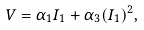<formula> <loc_0><loc_0><loc_500><loc_500>V = \alpha _ { 1 } I _ { 1 } + \alpha _ { 3 } ( I _ { 1 } ) ^ { 2 } ,</formula> 